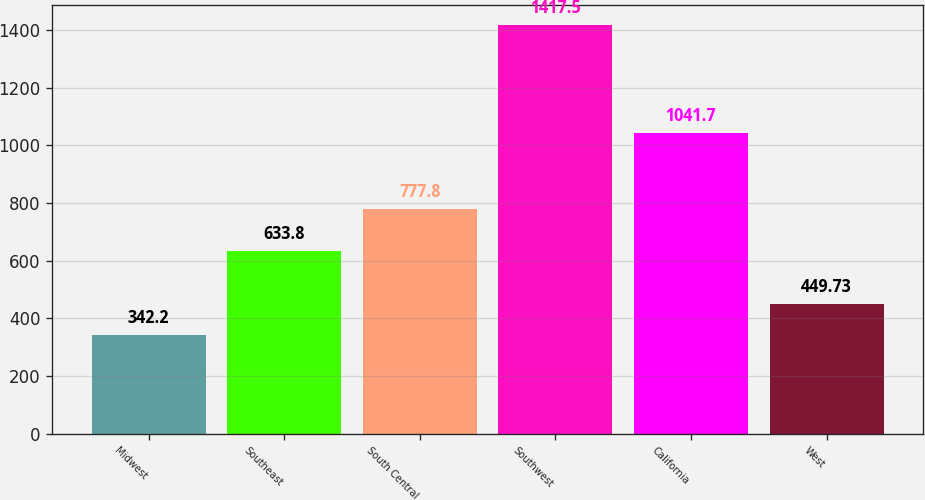<chart> <loc_0><loc_0><loc_500><loc_500><bar_chart><fcel>Midwest<fcel>Southeast<fcel>South Central<fcel>Southwest<fcel>California<fcel>West<nl><fcel>342.2<fcel>633.8<fcel>777.8<fcel>1417.5<fcel>1041.7<fcel>449.73<nl></chart> 